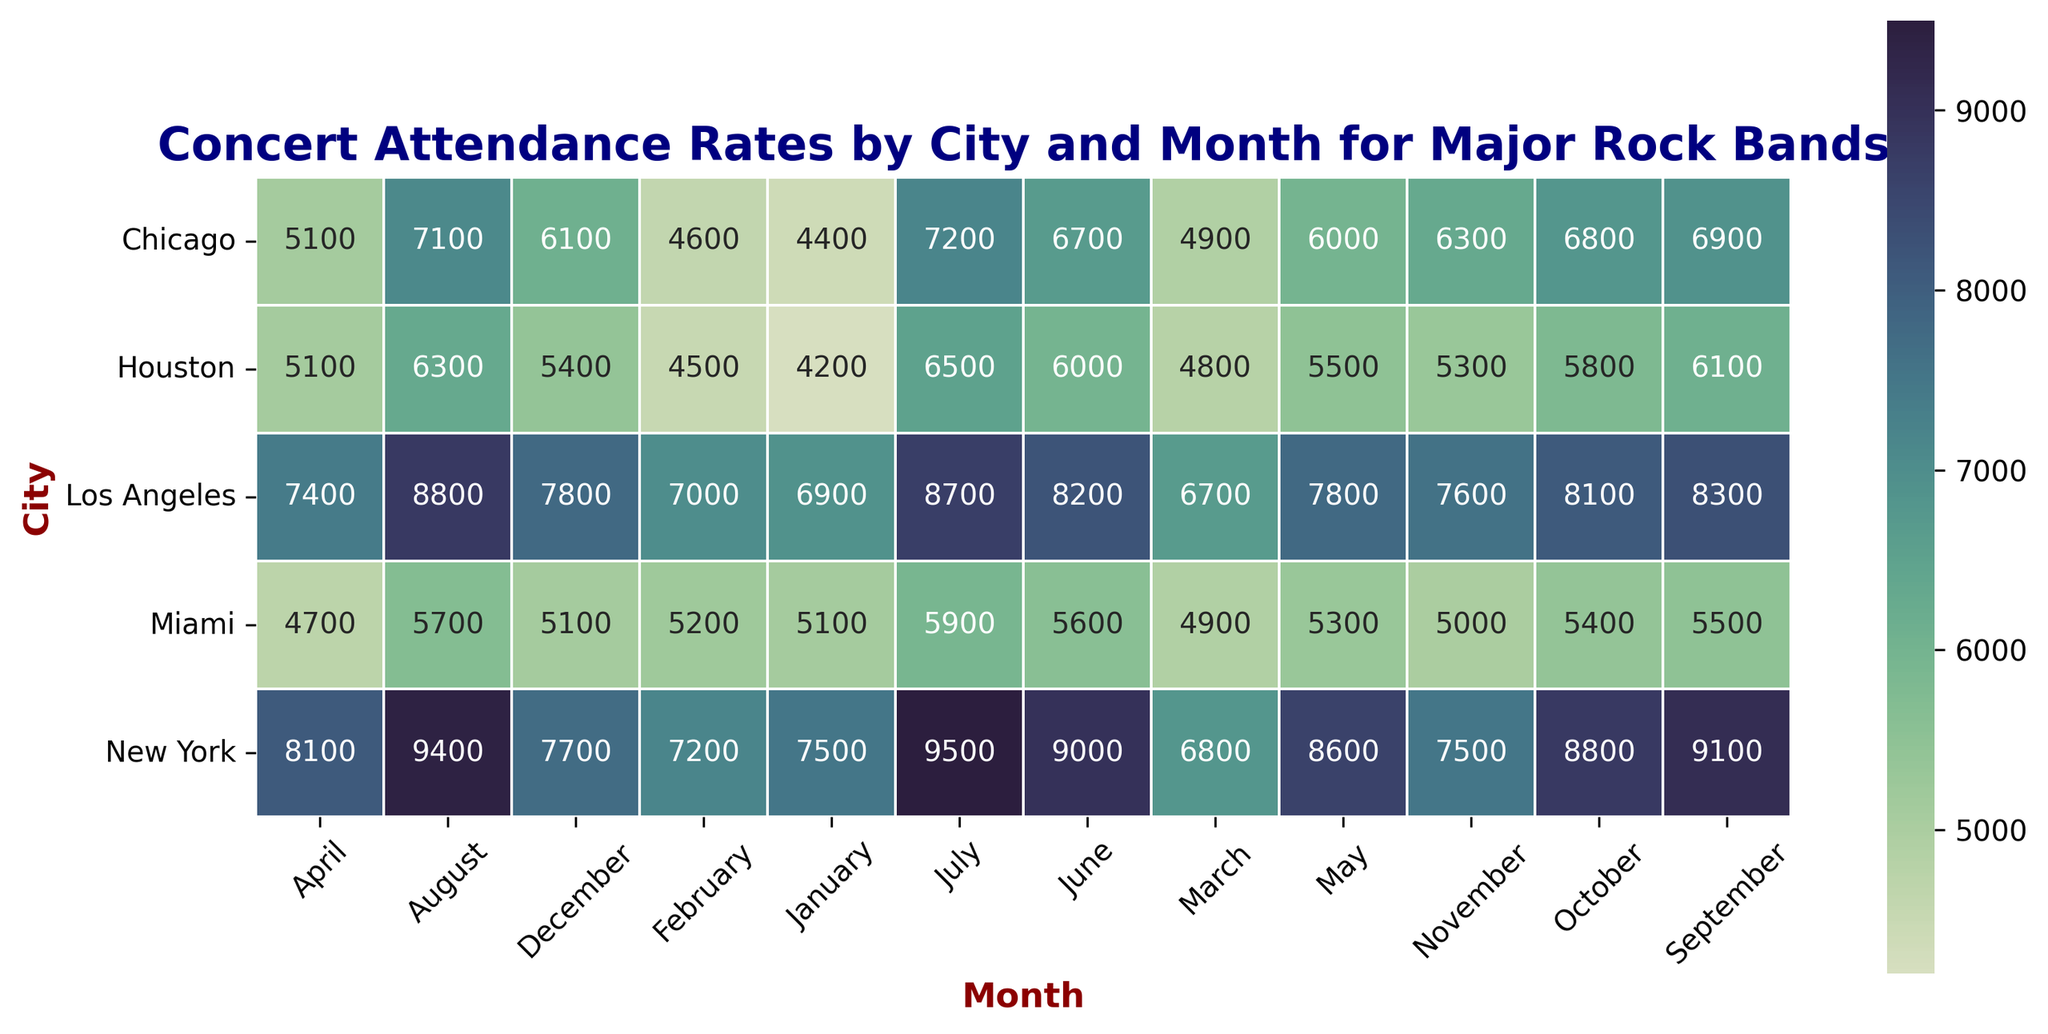What's the city with the highest attendance in July? First, locate the "July" column. Then, identify the highest value in this column and find its corresponding city. The highest value is 9500, which is in New York.
Answer: New York Which city has the lowest attendance in January? Observe the "January" column and find the smallest value. The lowest value in January is 4200, corresponding to Houston.
Answer: Houston What is the average attendance in New York from June to August? Sum the attendance values in New York for June, July, and August: 9000 + 9500 + 9400 = 27900. Then, divide by the number of months, which is 3. So, 27900 / 3 = 9300.
Answer: 9300 Is the attendance in Chicago higher in June or September? Compare the attendance values for Chicago in June and September. June has 6700, and September has 6900. Since 6900 > 6700, September has higher attendance.
Answer: September How does the concert attendance in May compare between Miami and Los Angeles? Check the numbers for May in both Miami and Los Angeles. Miami has 5300, and Los Angeles has 7800. Since 7800 > 5300, attendance in Los Angeles is higher.
Answer: Los Angeles What's the total attendance for Houston and Chicago combined in April? Add the attendance values for both cities in April: Houston (5100) + Chicago (5100) = 10200.
Answer: 10200 Which month shows the lowest attendance for Los Angeles? Examine the data for Los Angeles across all months to find the smallest value. The lowest attendance in Los Angeles is 6700, in March.
Answer: March What is the difference in attendance between November and December in New York? Subtract the November attendance from the December attendance in New York: 7700 - 7500 = 200.
Answer: 200 What is the trend in attendance rates for Miami from January to December? Analyze the month-by-month data for Miami. It starts at 5100 in January, increases slightly till June (5600), and then generally decreases towards the end of the year, ending at 5100 in December. This forms a slight peak around mid-year before dropping back.
Answer: Slight peak around mid-year, then drops 